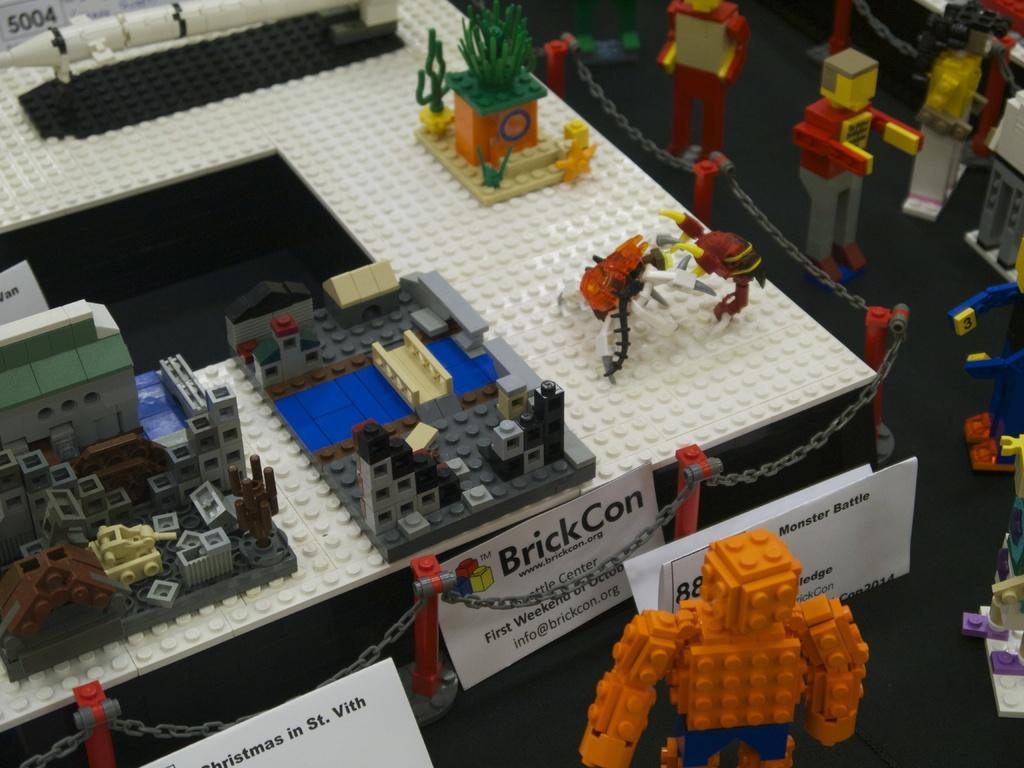Please provide a concise description of this image. In this image we can see some lego toys and papers with some text. 